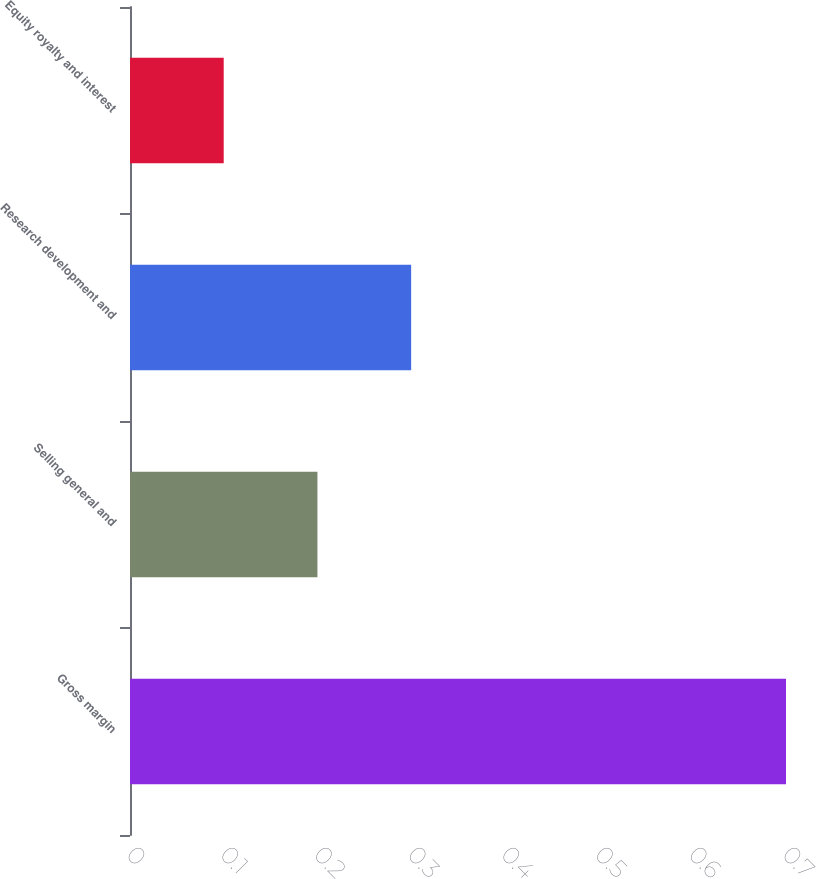<chart> <loc_0><loc_0><loc_500><loc_500><bar_chart><fcel>Gross margin<fcel>Selling general and<fcel>Research development and<fcel>Equity royalty and interest<nl><fcel>0.7<fcel>0.2<fcel>0.3<fcel>0.1<nl></chart> 